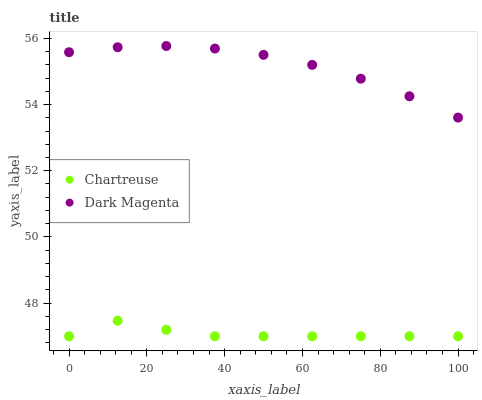Does Chartreuse have the minimum area under the curve?
Answer yes or no. Yes. Does Dark Magenta have the maximum area under the curve?
Answer yes or no. Yes. Does Dark Magenta have the minimum area under the curve?
Answer yes or no. No. Is Dark Magenta the smoothest?
Answer yes or no. Yes. Is Chartreuse the roughest?
Answer yes or no. Yes. Is Dark Magenta the roughest?
Answer yes or no. No. Does Chartreuse have the lowest value?
Answer yes or no. Yes. Does Dark Magenta have the lowest value?
Answer yes or no. No. Does Dark Magenta have the highest value?
Answer yes or no. Yes. Is Chartreuse less than Dark Magenta?
Answer yes or no. Yes. Is Dark Magenta greater than Chartreuse?
Answer yes or no. Yes. Does Chartreuse intersect Dark Magenta?
Answer yes or no. No. 